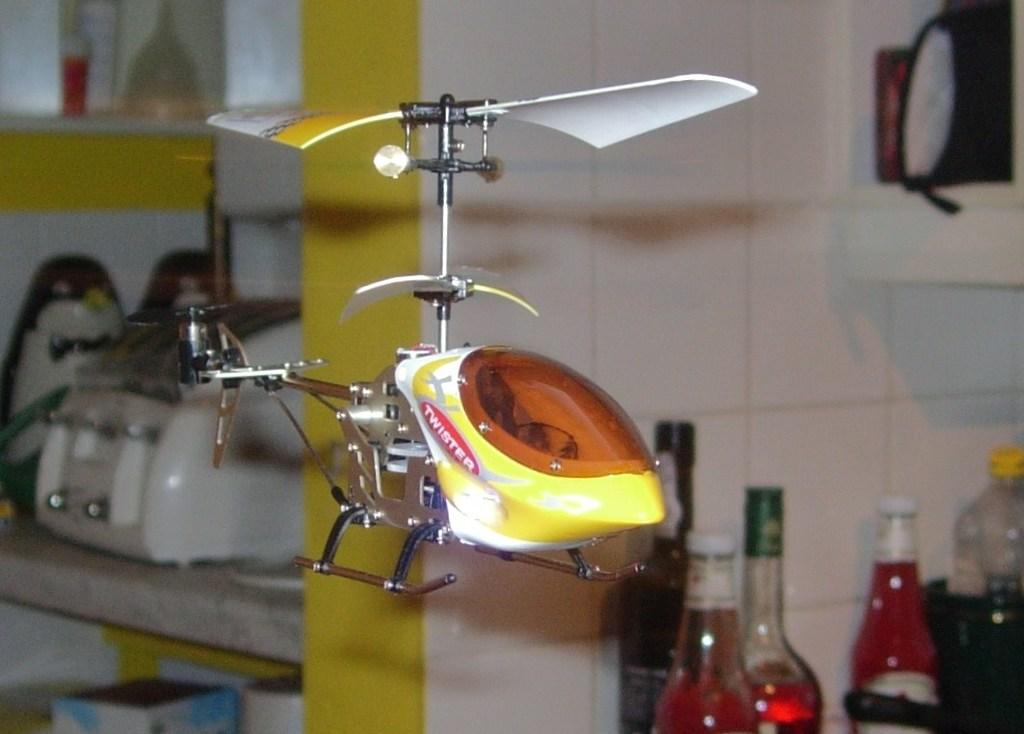What is the main subject in the center of the image? There is a toy helicopter in the center of the image. What else can be seen on the right side of the image? There are bottles on the right side of the image. How does the toy helicopter increase in size in the image? The toy helicopter does not increase in size in the image; it remains the same size throughout. 